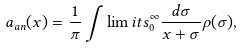Convert formula to latex. <formula><loc_0><loc_0><loc_500><loc_500>a _ { a n } ( x ) = \frac { 1 } { \pi } \int \lim i t s _ { 0 } ^ { \infty } \frac { d \sigma } { x + \sigma } \rho ( \sigma ) ,</formula> 